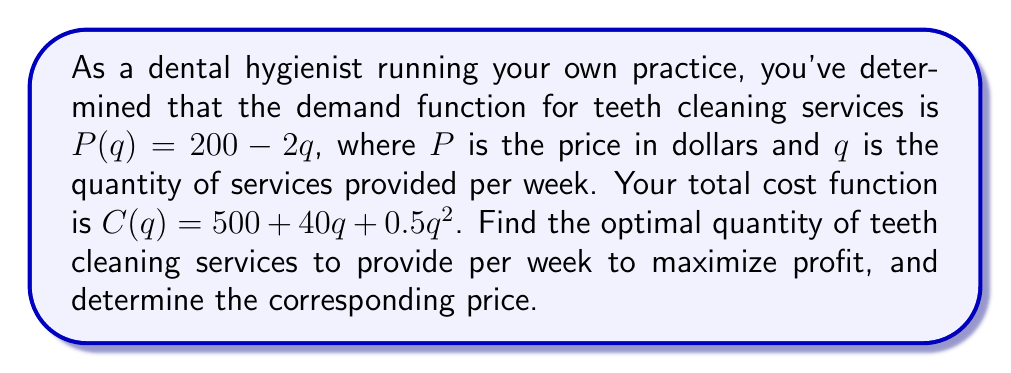Show me your answer to this math problem. 1. To maximize profit, we need to find the quantity where marginal revenue (MR) equals marginal cost (MC).

2. First, let's find the revenue function:
   $R(q) = P(q) \cdot q = (200 - 2q)q = 200q - 2q^2$

3. Now, let's derive the marginal revenue function:
   $MR(q) = \frac{dR}{dq} = 200 - 4q$

4. Next, let's derive the marginal cost function:
   $MC(q) = \frac{dC}{dq} = 40 + q$

5. Set MR equal to MC and solve for q:
   $200 - 4q = 40 + q$
   $160 = 5q$
   $q = 32$

6. To find the optimal price, substitute q = 32 into the demand function:
   $P(32) = 200 - 2(32) = 200 - 64 = 136$

7. Verify that this is a maximum by checking the second derivative of the profit function:
   $\Pi(q) = R(q) - C(q) = 200q - 2q^2 - (500 + 40q + 0.5q^2)$
   $\frac{d^2\Pi}{dq^2} = -4 - 1 = -5 < 0$, confirming a maximum.
Answer: Optimal quantity: 32 services/week; Optimal price: $136/service 